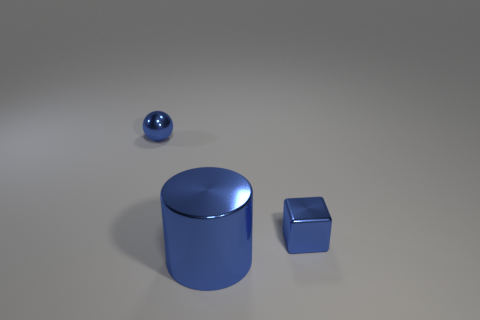Add 2 tiny shiny objects. How many objects exist? 5 Subtract all cylinders. How many objects are left? 2 Add 1 small blue balls. How many small blue balls exist? 2 Subtract 0 gray balls. How many objects are left? 3 Subtract all blue cubes. Subtract all tiny purple rubber balls. How many objects are left? 2 Add 1 cylinders. How many cylinders are left? 2 